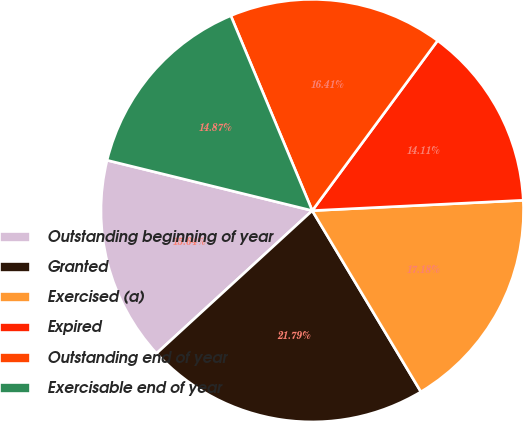Convert chart. <chart><loc_0><loc_0><loc_500><loc_500><pie_chart><fcel>Outstanding beginning of year<fcel>Granted<fcel>Exercised (a)<fcel>Expired<fcel>Outstanding end of year<fcel>Exercisable end of year<nl><fcel>15.64%<fcel>21.79%<fcel>17.18%<fcel>14.11%<fcel>16.41%<fcel>14.87%<nl></chart> 